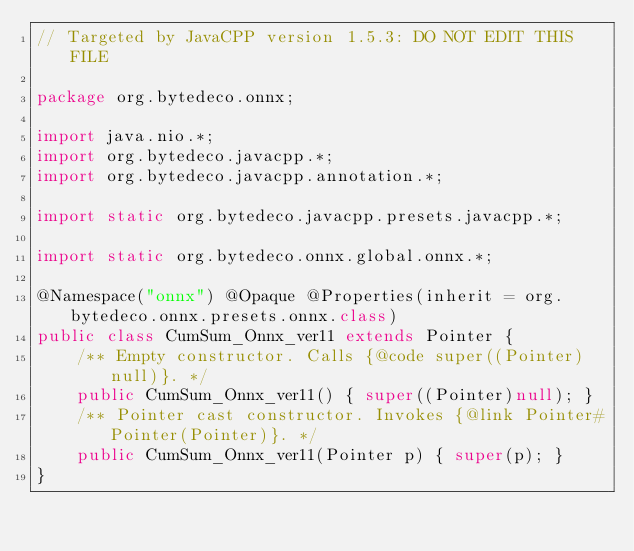<code> <loc_0><loc_0><loc_500><loc_500><_Java_>// Targeted by JavaCPP version 1.5.3: DO NOT EDIT THIS FILE

package org.bytedeco.onnx;

import java.nio.*;
import org.bytedeco.javacpp.*;
import org.bytedeco.javacpp.annotation.*;

import static org.bytedeco.javacpp.presets.javacpp.*;

import static org.bytedeco.onnx.global.onnx.*;

@Namespace("onnx") @Opaque @Properties(inherit = org.bytedeco.onnx.presets.onnx.class)
public class CumSum_Onnx_ver11 extends Pointer {
    /** Empty constructor. Calls {@code super((Pointer)null)}. */
    public CumSum_Onnx_ver11() { super((Pointer)null); }
    /** Pointer cast constructor. Invokes {@link Pointer#Pointer(Pointer)}. */
    public CumSum_Onnx_ver11(Pointer p) { super(p); }
}
</code> 